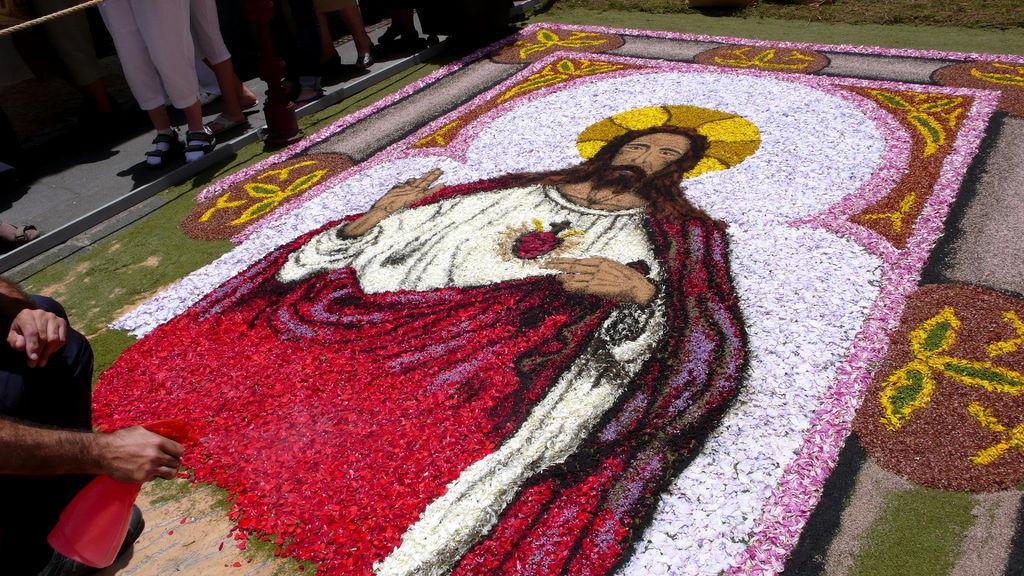What is the person in the image doing? The person in the image is making a picture. What materials is the person using to create the picture? The person is using flowers to create the picture. Who or what is the subject of the picture? The subject of the picture is another person on the floor. Can you describe the people standing to the left of the image? There are many people standing to the left of the image, but their specific characteristics are not mentioned in the facts. What type of veil is covering the cake in the image? There is no cake or veil present in the image. How does the wealth of the person on the floor affect the picture being made? The facts provided do not mention anything about the wealth of the person on the floor, so it cannot be determined how it might affect the picture being made. 